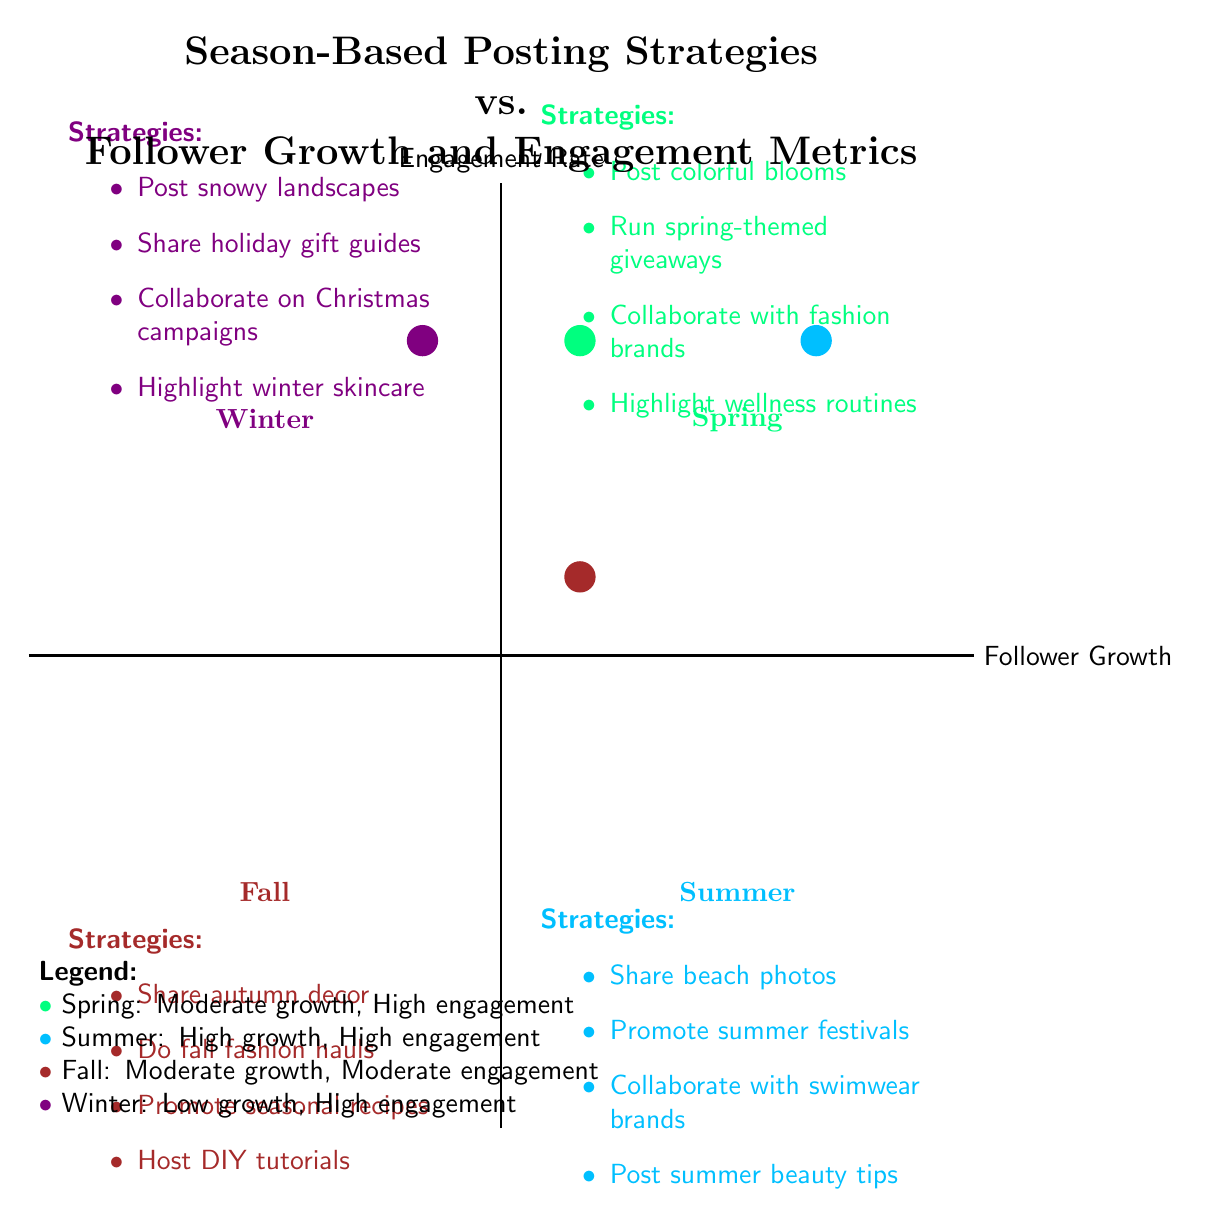What's the engagement rate for the Summer quadrant? The Summer quadrant is located in the bottom right section of the diagram, where it indicates a "High" engagement rate.
Answer: High Which season shows the lowest follower growth? The Winter quadrant, located in the top left of the diagram, specifies a "Low" follower growth.
Answer: Low How many strategies are listed for the Fall season? In the Fall quadrant, there are four strategies detailed in a bulleted list, confirming the count is four.
Answer: Four What is the engagement rate for Winter? Looking at the Winter quadrant, it clearly indicates a "High" engagement rate as per the metrics associated with this season.
Answer: High Which season has a collaboration with swimwear brands? The Summer quadrant lists a strategy for collaboration with swimwear brands, positioning it as the season focused on such collaborations.
Answer: Summer Compare the follower growth between Spring and Fall. The Spring quadrant indicates "Moderate" follower growth, while the Fall quadrant also indicates "Moderate" follower growth, showing they are the same.
Answer: Same What type of content is recommended in the Spring quadrant? The Spring quadrant highlights strategies such as posting colorful blooms, which aligns with the overarching theme of rejuvenation and renewal for that season.
Answer: Colorful blooms How does the follower growth in Summer compare to Winter? Summer's follower growth is categorized as "High," while Winter's is "Low," demonstrating a significant difference favoring Summer.
Answer: Higher Which strategy from the Winter quadrant focuses on holiday preparation? The Winter quadrant suggests sharing holiday gift guides and shopping tips as a strategy tailored to holiday preparation.
Answer: Holiday gift guides 